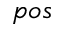Convert formula to latex. <formula><loc_0><loc_0><loc_500><loc_500>p o s</formula> 